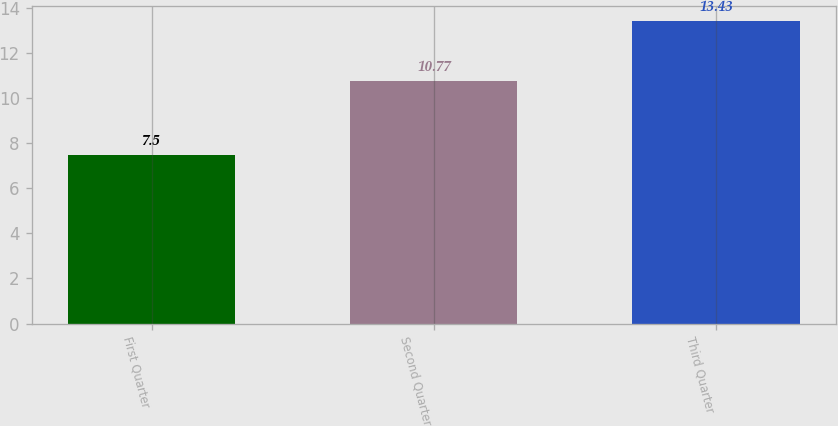Convert chart to OTSL. <chart><loc_0><loc_0><loc_500><loc_500><bar_chart><fcel>First Quarter<fcel>Second Quarter<fcel>Third Quarter<nl><fcel>7.5<fcel>10.77<fcel>13.43<nl></chart> 